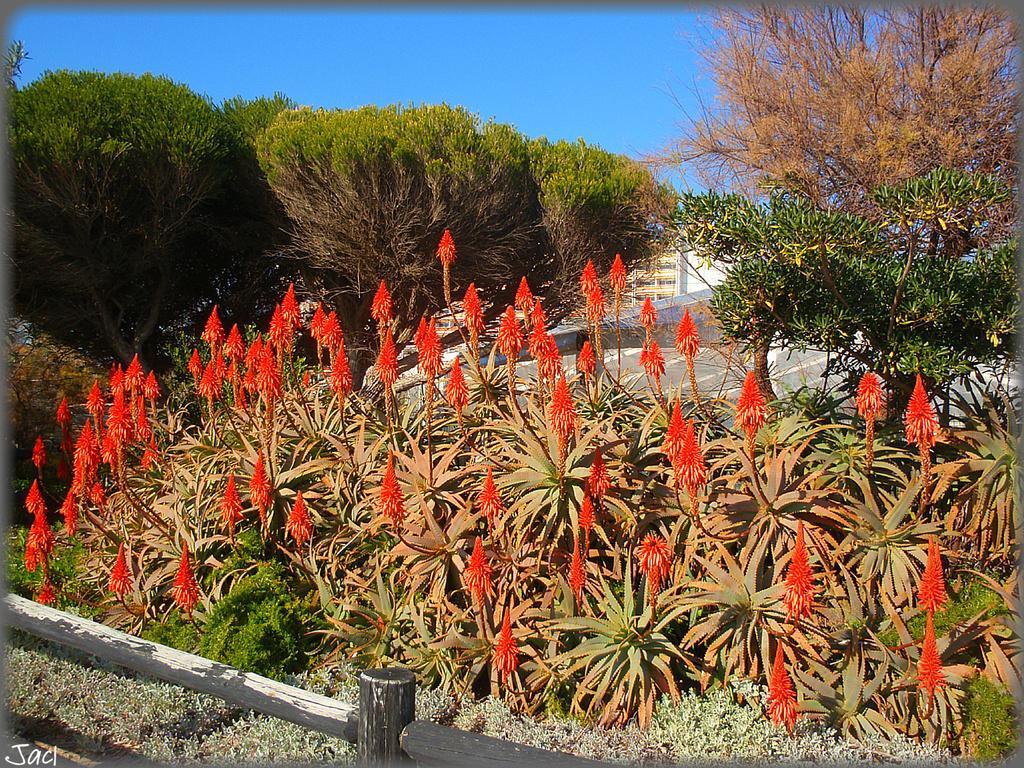Could you give a brief overview of what you see in this image? In this picture we can see few flowers, plants and trees, in the background we can find a building. 